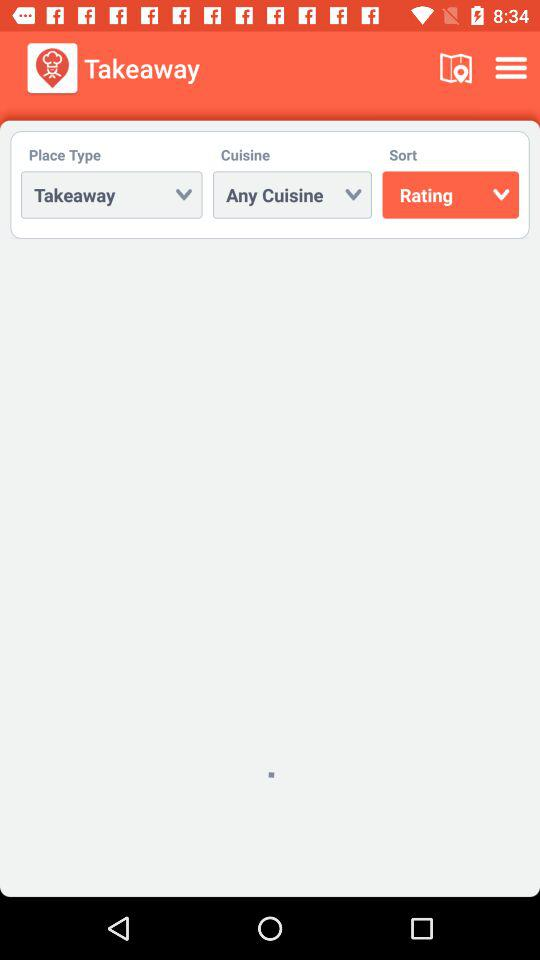Which place type is selected? The selected place type is "Takeaway". 